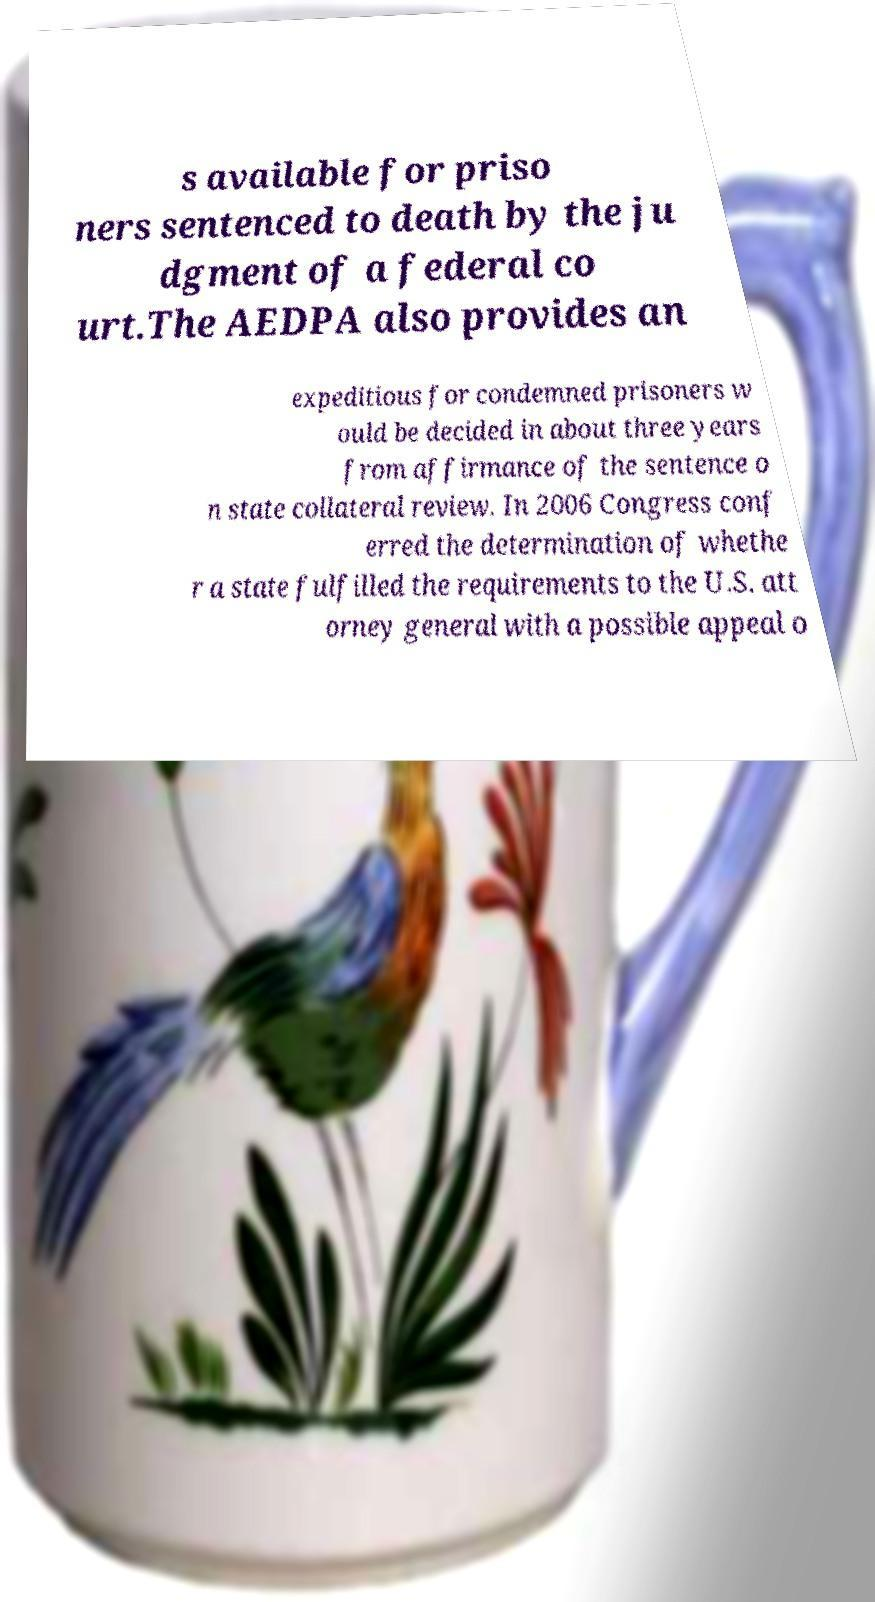Could you extract and type out the text from this image? s available for priso ners sentenced to death by the ju dgment of a federal co urt.The AEDPA also provides an expeditious for condemned prisoners w ould be decided in about three years from affirmance of the sentence o n state collateral review. In 2006 Congress conf erred the determination of whethe r a state fulfilled the requirements to the U.S. att orney general with a possible appeal o 